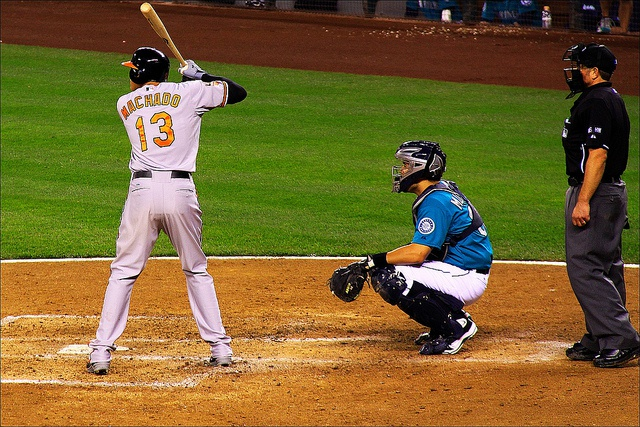Describe the objects in this image and their specific colors. I can see people in black, lavender, pink, and darkgray tones, people in black, maroon, brown, and darkgreen tones, people in black, lavender, blue, and navy tones, baseball glove in black, white, red, and maroon tones, and people in black, gray, navy, and violet tones in this image. 